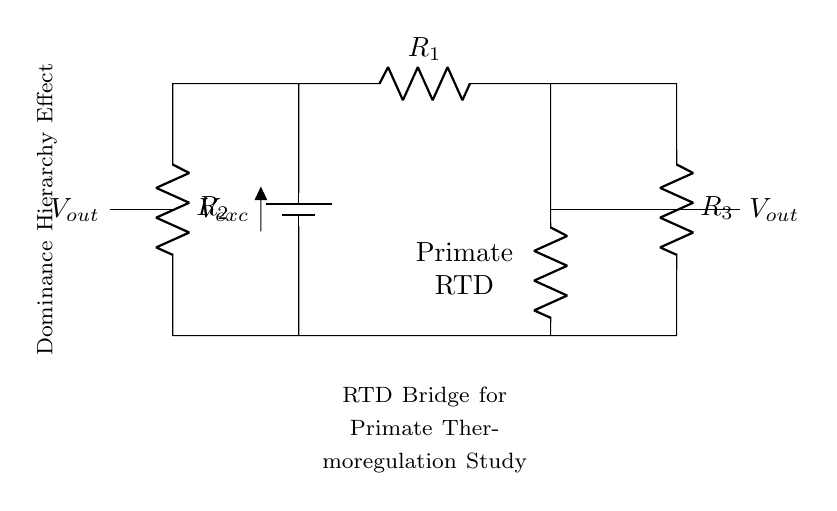What is the excitation voltage in the circuit? The excitation voltage is marked as Vexc on the battery component at the top of the circuit. To locate it, observe that it connects to the resistors and the RTD.
Answer: Vexc What components are used in this RTD bridge circuit? The components in the circuit include a battery (for excitation voltage), three resistors (R1, R2, R3), and a resistance temperature detector represented as RRTD. This can be identified by examining each labeled component in the diagram.
Answer: Battery, R1, R2, R3, RRTD What is the role of the RRTD in this circuit? The RRTD serves as the temperature sensing element, indicating temperature changes based on its resistance variation when connected in the bridge configuration. The location labeled indicates it is involved in measuring temperature for the study.
Answer: Temperature sensing How many resistors are in the circuit? By counting the labeled resistors (R1, R2, R3), there are three resistors present in the circuit connected in a bridge configuration.
Answer: Three What indicates the output voltage of the bridge? The output voltage is indicated by two nodes labeled Vout on the right and left sides of the circuit, where the measurement will be taken from the points between R1, RRTD, and the resistor bridge.
Answer: Vout How does this circuit help study primate thermoregulation? The RTD provides precise temperature readings that can vary with the primate's dominance hierarchy position, making it essential for understanding how social factors influence thermoregulation. This analysis is evident from the labeling and description.
Answer: By measuring temperature In which configuration is the RTD employed to measure temperature? The RTD is employed in a bridge configuration, which is designed to balance the circuit for precise temperature readings. This can be observed where the RTD is connected to other resistors.
Answer: Bridge configuration 